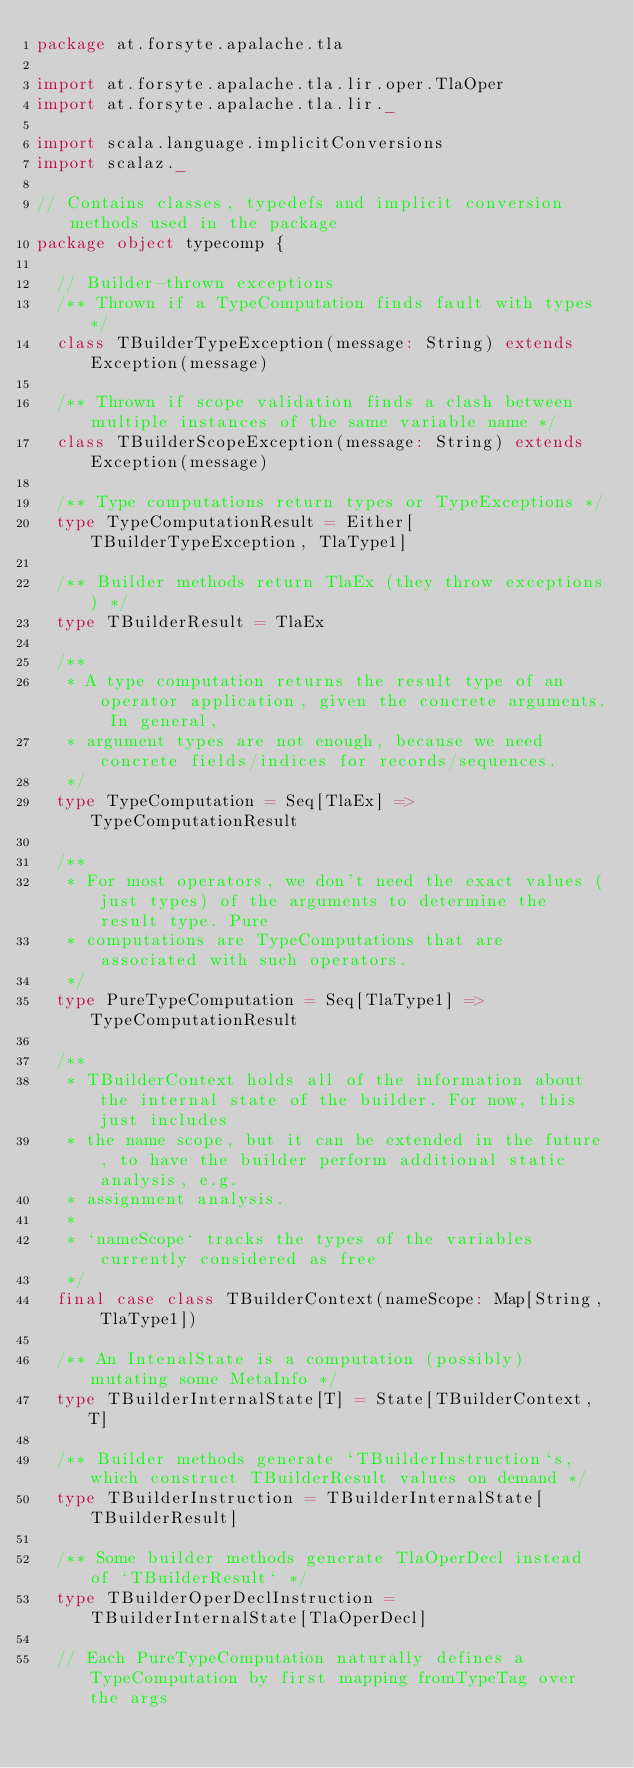Convert code to text. <code><loc_0><loc_0><loc_500><loc_500><_Scala_>package at.forsyte.apalache.tla

import at.forsyte.apalache.tla.lir.oper.TlaOper
import at.forsyte.apalache.tla.lir._

import scala.language.implicitConversions
import scalaz._

// Contains classes, typedefs and implicit conversion methods used in the package
package object typecomp {

  // Builder-thrown exceptions
  /** Thrown if a TypeComputation finds fault with types */
  class TBuilderTypeException(message: String) extends Exception(message)

  /** Thrown if scope validation finds a clash between multiple instances of the same variable name */
  class TBuilderScopeException(message: String) extends Exception(message)

  /** Type computations return types or TypeExceptions */
  type TypeComputationResult = Either[TBuilderTypeException, TlaType1]

  /** Builder methods return TlaEx (they throw exceptions) */
  type TBuilderResult = TlaEx

  /**
   * A type computation returns the result type of an operator application, given the concrete arguments. In general,
   * argument types are not enough, because we need concrete fields/indices for records/sequences.
   */
  type TypeComputation = Seq[TlaEx] => TypeComputationResult

  /**
   * For most operators, we don't need the exact values (just types) of the arguments to determine the result type. Pure
   * computations are TypeComputations that are associated with such operators.
   */
  type PureTypeComputation = Seq[TlaType1] => TypeComputationResult

  /**
   * TBuilderContext holds all of the information about the internal state of the builder. For now, this just includes
   * the name scope, but it can be extended in the future, to have the builder perform additional static analysis, e.g.
   * assignment analysis.
   *
   * `nameScope` tracks the types of the variables currently considered as free
   */
  final case class TBuilderContext(nameScope: Map[String, TlaType1])

  /** An IntenalState is a computation (possibly) mutating some MetaInfo */
  type TBuilderInternalState[T] = State[TBuilderContext, T]

  /** Builder methods generate `TBuilderInstruction`s, which construct TBuilderResult values on demand */
  type TBuilderInstruction = TBuilderInternalState[TBuilderResult]

  /** Some builder methods generate TlaOperDecl instead of `TBuilderResult` */
  type TBuilderOperDeclInstruction = TBuilderInternalState[TlaOperDecl]

  // Each PureTypeComputation naturally defines a TypeComputation by first mapping fromTypeTag over the args</code> 